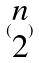Convert formula to latex. <formula><loc_0><loc_0><loc_500><loc_500>( \begin{matrix} n \\ 2 \end{matrix} )</formula> 